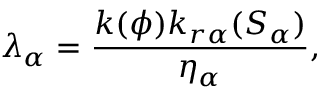Convert formula to latex. <formula><loc_0><loc_0><loc_500><loc_500>\lambda _ { \alpha } = \frac { k ( \phi ) k _ { r \alpha } ( S _ { \alpha } ) } { \eta _ { \alpha } } ,</formula> 